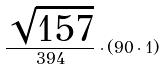<formula> <loc_0><loc_0><loc_500><loc_500>\frac { \sqrt { 1 5 7 } } { 3 9 4 } \cdot ( 9 0 \cdot 1 )</formula> 